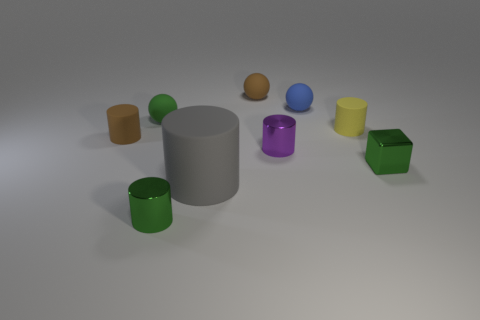How many small green metallic objects are behind the gray rubber thing to the left of the blue matte object? There is one small green metallic object situated behind the gray cylindrical item, which is positioned to the left of the blue matte object. 